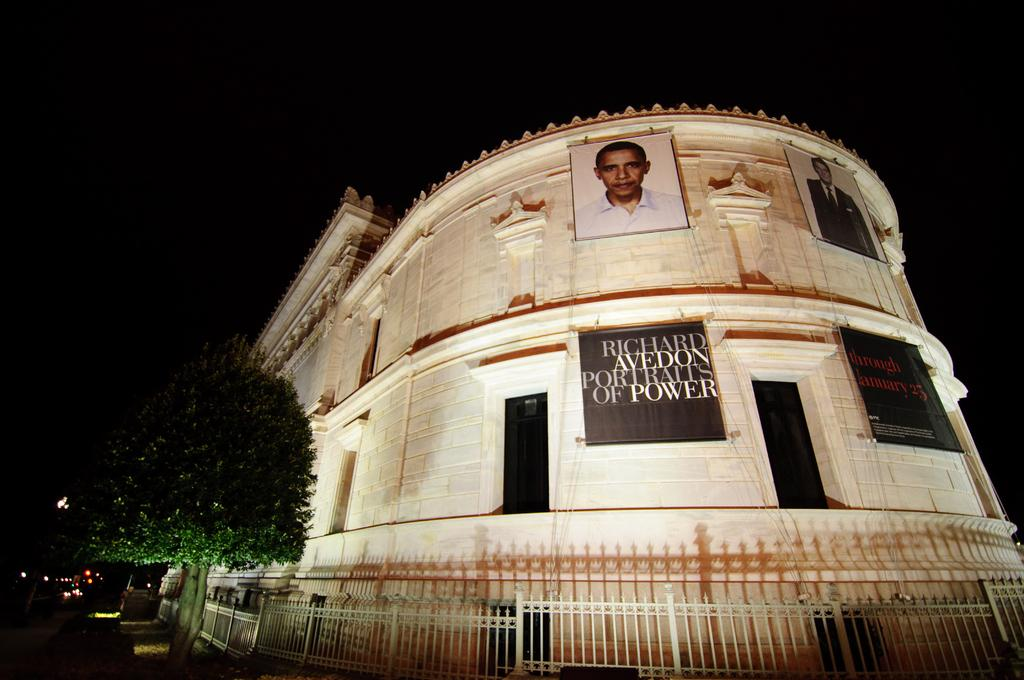What type of structure is visible in the image? There is a building in the image. What is located near the building? There are banners near the building. What type of natural elements can be seen in the image? There are trees in the image. What type of barrier is present in the image? There is fencing in the image. What type of illumination is present in the image? There are lights in the image. What is the color of the background in the image? The background of the image is black. What type of patch is sewn onto the toy in the image? There is no toy or patch present in the image. What feeling does the person in the image seem to be experiencing? There is no person present in the image, so it is impossible to determine their feelings. 